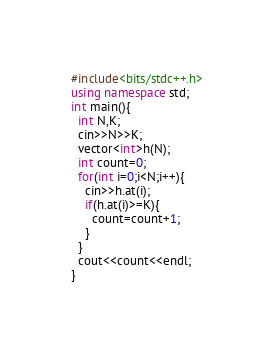Convert code to text. <code><loc_0><loc_0><loc_500><loc_500><_C++_>#include<bits/stdc++.h>
using namespace std;
int main(){
  int N,K;
  cin>>N>>K;
  vector<int>h(N);
  int count=0;
  for(int i=0;i<N;i++){
    cin>>h.at(i);
    if(h.at(i)>=K){
      count=count+1;
    }
  }
  cout<<count<<endl;
}</code> 